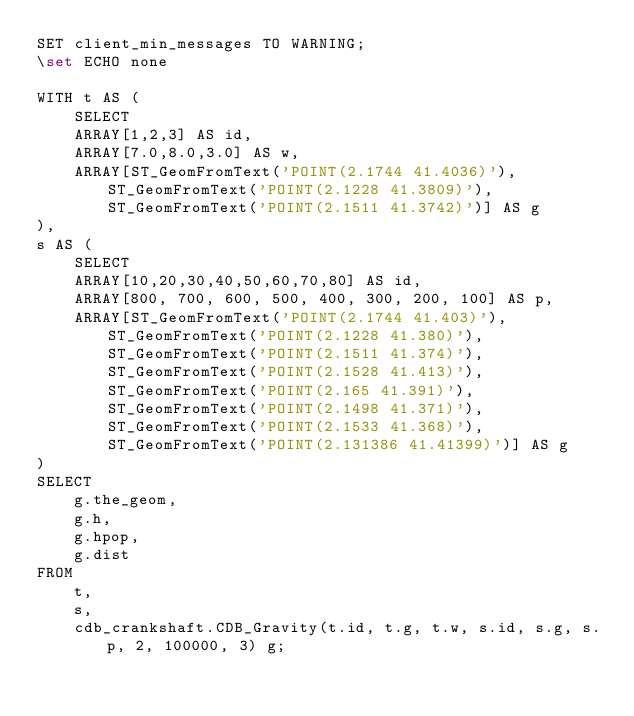Convert code to text. <code><loc_0><loc_0><loc_500><loc_500><_SQL_>SET client_min_messages TO WARNING;
\set ECHO none

WITH t AS (
    SELECT
    ARRAY[1,2,3] AS id,
    ARRAY[7.0,8.0,3.0] AS w,
    ARRAY[ST_GeomFromText('POINT(2.1744 41.4036)'),ST_GeomFromText('POINT(2.1228 41.3809)'),ST_GeomFromText('POINT(2.1511 41.3742)')] AS g
),
s AS (
    SELECT
    ARRAY[10,20,30,40,50,60,70,80] AS id,
    ARRAY[800, 700, 600, 500, 400, 300, 200, 100] AS p,
    ARRAY[ST_GeomFromText('POINT(2.1744 41.403)'),ST_GeomFromText('POINT(2.1228 41.380)'),ST_GeomFromText('POINT(2.1511 41.374)'),ST_GeomFromText('POINT(2.1528 41.413)'),ST_GeomFromText('POINT(2.165 41.391)'),ST_GeomFromText('POINT(2.1498 41.371)'),ST_GeomFromText('POINT(2.1533 41.368)'),ST_GeomFromText('POINT(2.131386 41.41399)')] AS g
)
SELECT
    g.the_geom,
    g.h,
    g.hpop,
    g.dist
FROM
    t,
    s,
    cdb_crankshaft.CDB_Gravity(t.id, t.g, t.w, s.id, s.g, s.p, 2, 100000, 3) g;
</code> 